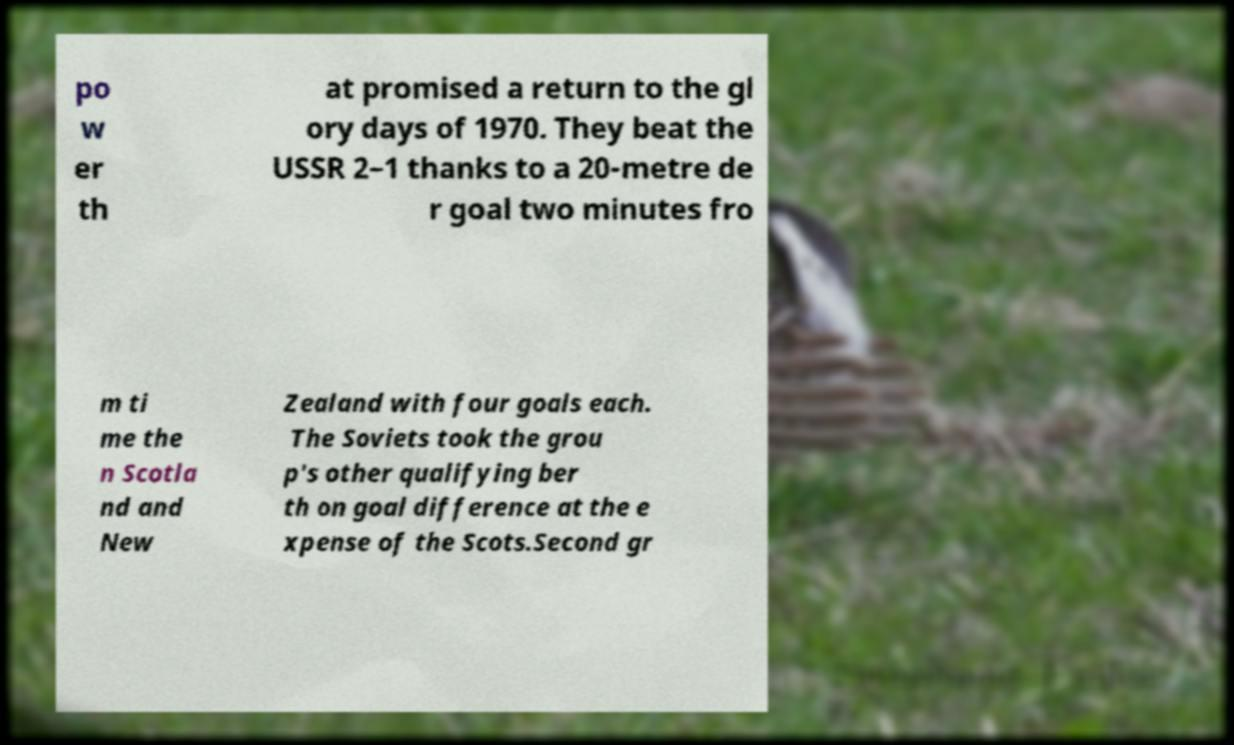Could you assist in decoding the text presented in this image and type it out clearly? po w er th at promised a return to the gl ory days of 1970. They beat the USSR 2–1 thanks to a 20-metre de r goal two minutes fro m ti me the n Scotla nd and New Zealand with four goals each. The Soviets took the grou p's other qualifying ber th on goal difference at the e xpense of the Scots.Second gr 